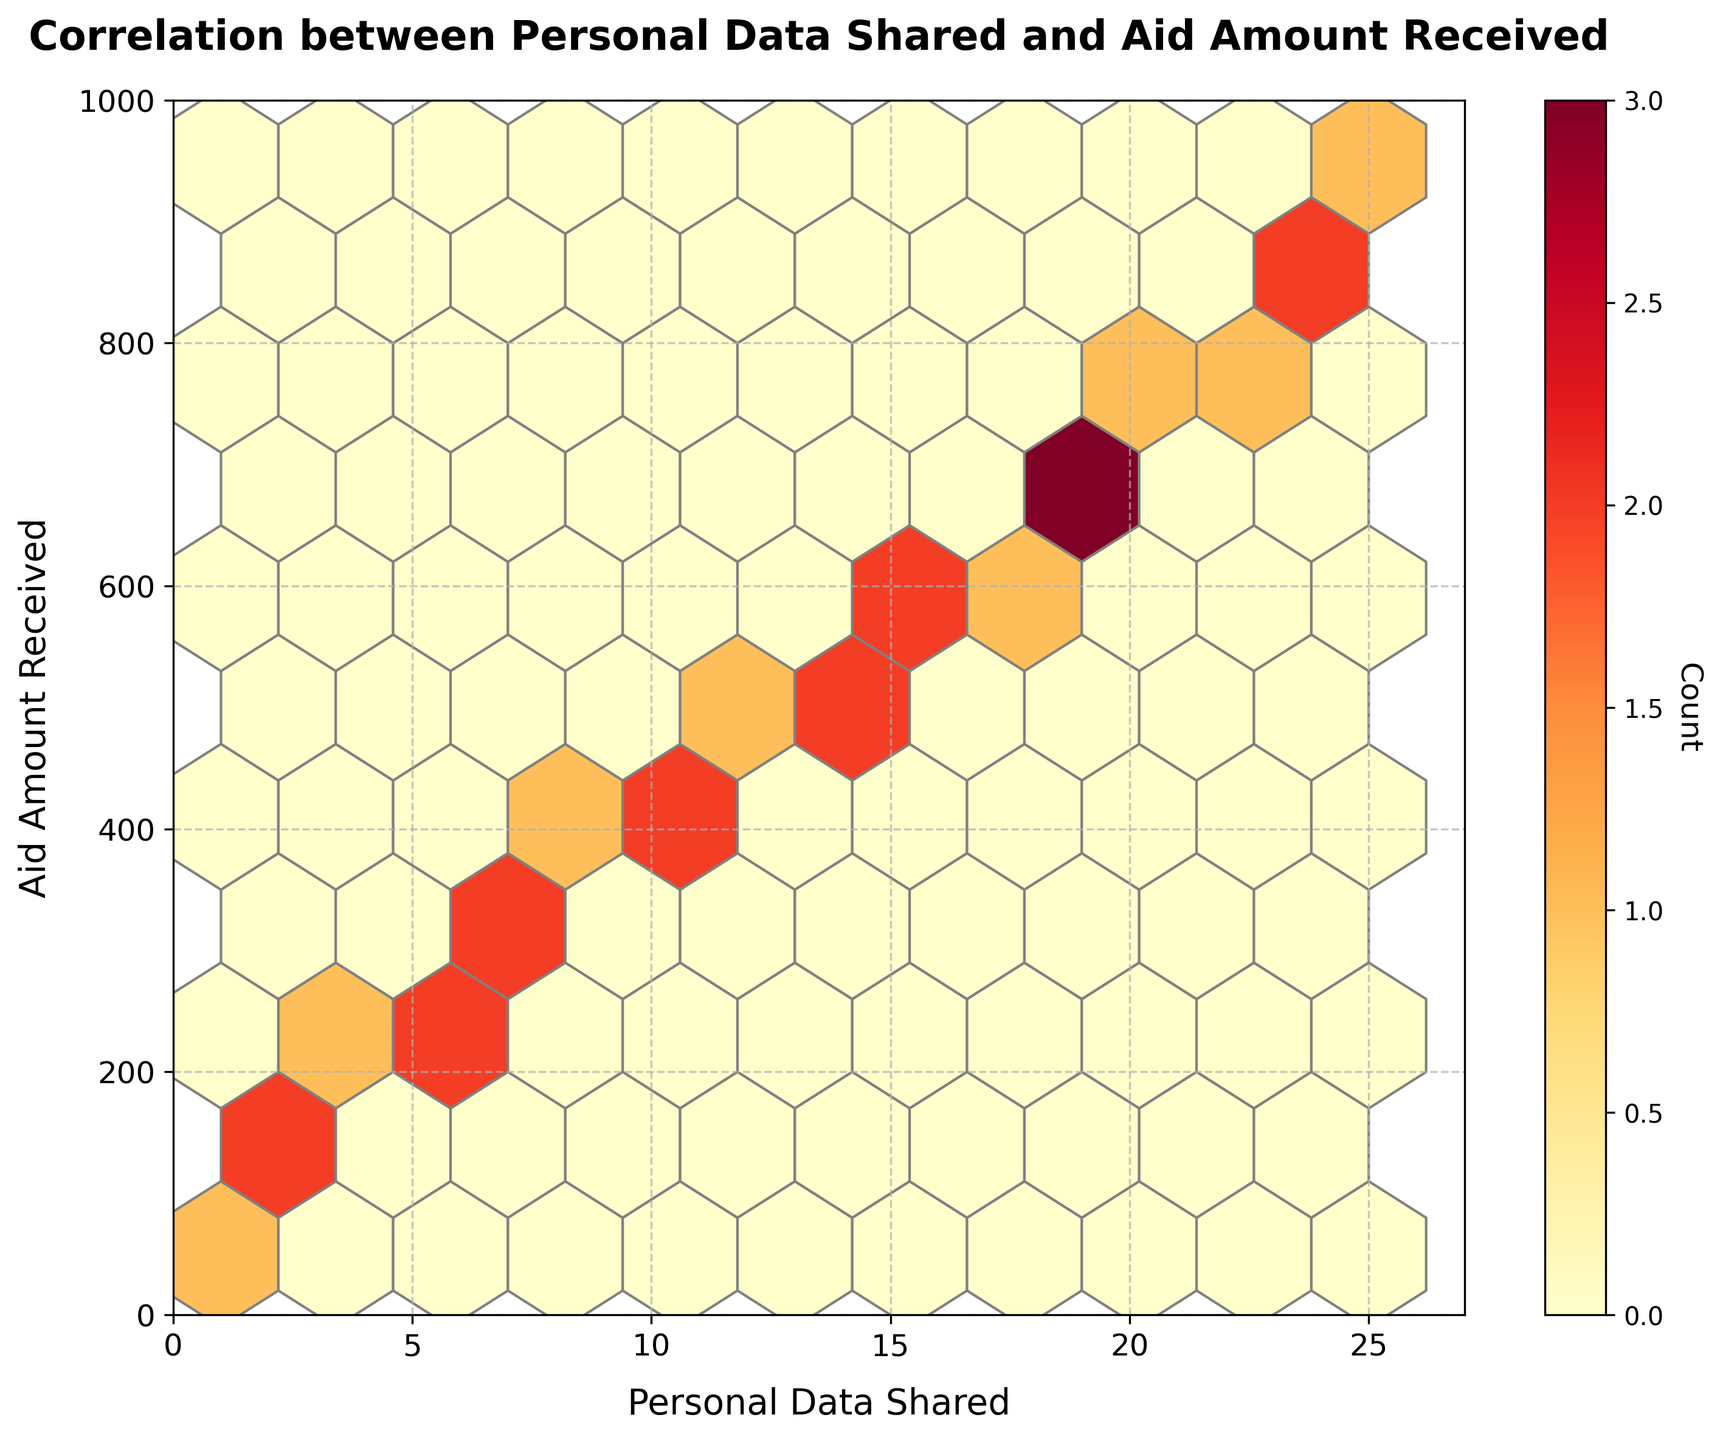What is the title of the plot? Look at the top of the figure where the title is usually placed. The title reads "Correlation between Personal Data Shared and Aid Amount Received".
Answer: Correlation between Personal Data Shared and Aid Amount Received What are the labels of the x and y axes? The x-axis label can be found below the horizontal axis, and the y-axis label can be found to the left of the vertical axis. The labels are "Personal Data Shared" for the x-axis and "Aid Amount Received" for the y-axis.
Answer: Personal Data Shared and Aid Amount Received How many bins are there in the plot? The parameter "gridsize" in the hexbin function determines the number of bins in the plot. Here it is set to 10, which implies the figure has a grid of 10x10 bins.
Answer: 100 What does the color represent in this hexbin plot? Color intensity in a hexbin plot shows the density of data points. In this figure, darker areas represent bins with more data points, as indicated by the color bar.
Answer: Density of data points Which bin has the highest density? The bin with the highest density is recognizable by its darkest color. The color bar shows that the highest density bin has the most intense color.
Answer: Bin with highest color intensity What is the range of values for Personal Data Shared on the x-axis? Check the limits set on the x-axis of the figure. The range starts from 0 and goes slightly beyond the maximum data value, which is 25, so the range of values is from 0 to 27.
Answer: 0 to 27 What is the range of values for Aid Amount Received on the y-axis? Check the limits set on the y-axis of the figure. The range starts from 0 and goes slightly beyond the maximum data value, which is 950, so the range of values is from 0 to 1000.
Answer: 0 to 1000 Do you observe any correlation trend between Personal Data Shared and Aid Amount Received? In a hexbin plot, a positive linear correlation can be seen if the densest bins form a roughly diagonal line upwards from the left. Here, as the amount of Personal Data Shared increases, the Aid Amount Received also appears to increase.
Answer: Positive correlation How is the density information conveyed in the plot? The density information is conveyed using color intensity, with darker colors indicating higher counts of data points within each hexagonal bin. The color bar on the side further elucidates the count associated with each color.
Answer: Color intensity Is there a specific range of Personal Data Shared values that tend to receive a higher Aid Amount? By focusing on denser regions in the plot, we observe that when Personal Data Shared is between 10 and 20, the Aid Amount Received is often higher. Inspecting the densest bins reveals this trend.
Answer: 10 to 20 